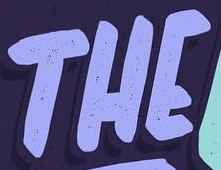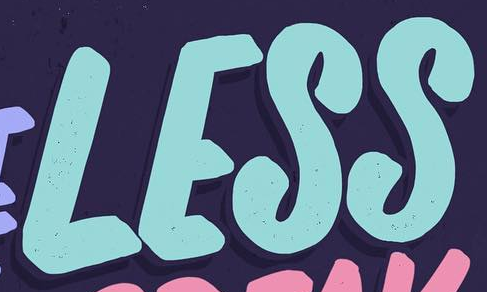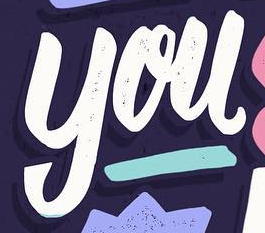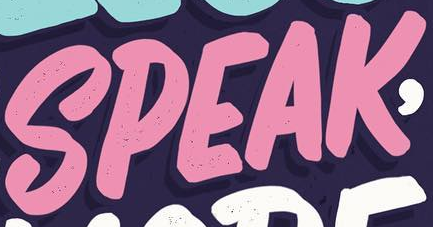What text is displayed in these images sequentially, separated by a semicolon? THE; LESS; you; SPEAK 